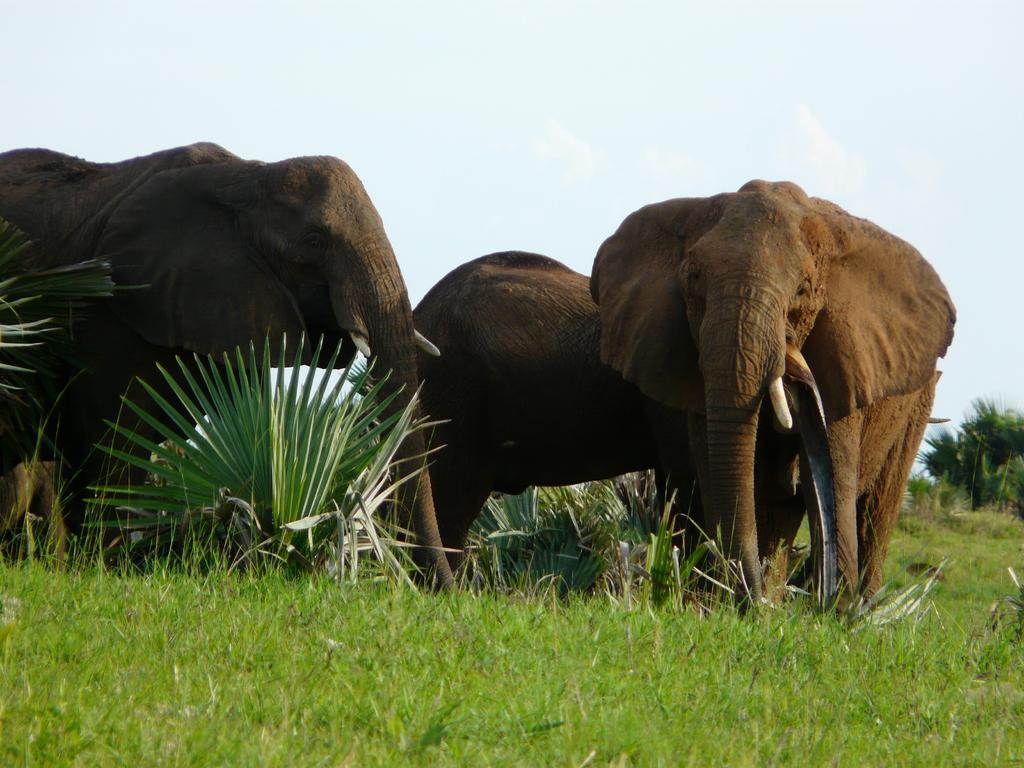What is the main subject of the image? There is a herd of animals in the image. How are the animals positioned in the image? The animals are standing on the ground. What can be seen in the background of the image? There are trees and the sky visible in the background of the image. How many toads are sitting on the branches of the trees in the image? There are no toads present in the image; it features a herd of animals standing on the ground. What type of bird can be seen flying in the sky in the image? There are no birds visible in the sky in the image; only the herd of animals, trees, and the sky are present. 